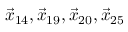Convert formula to latex. <formula><loc_0><loc_0><loc_500><loc_500>\vec { x } _ { 1 4 } , \vec { x } _ { 1 9 } , \vec { x } _ { 2 0 } , \vec { x } _ { 2 5 }</formula> 